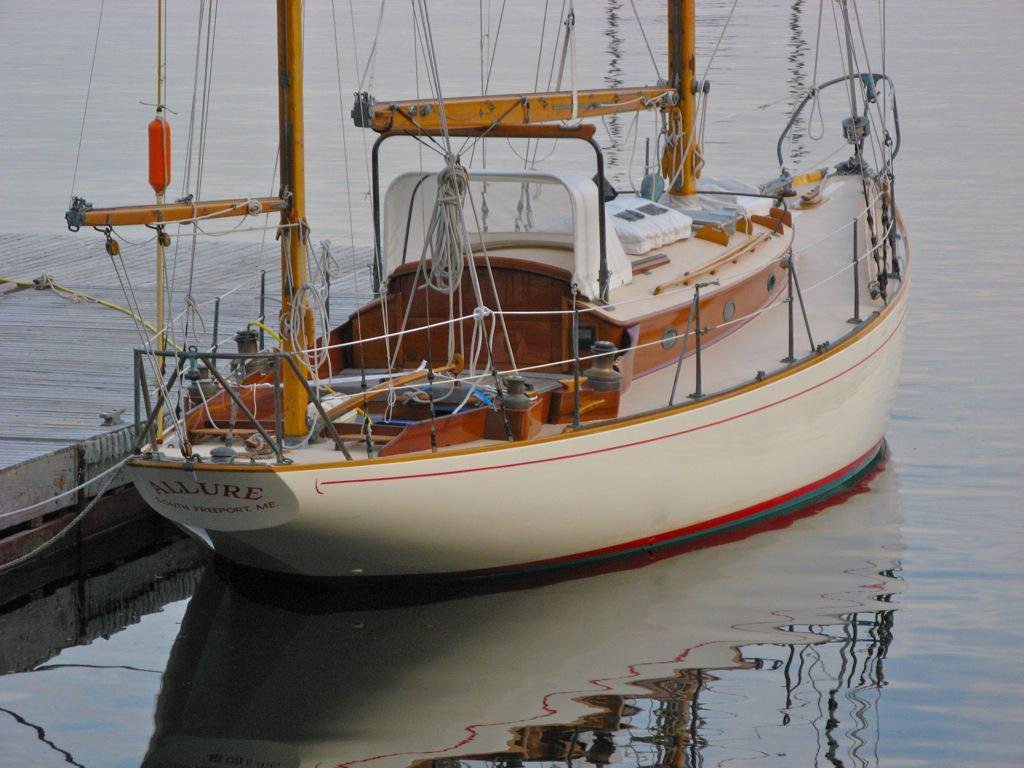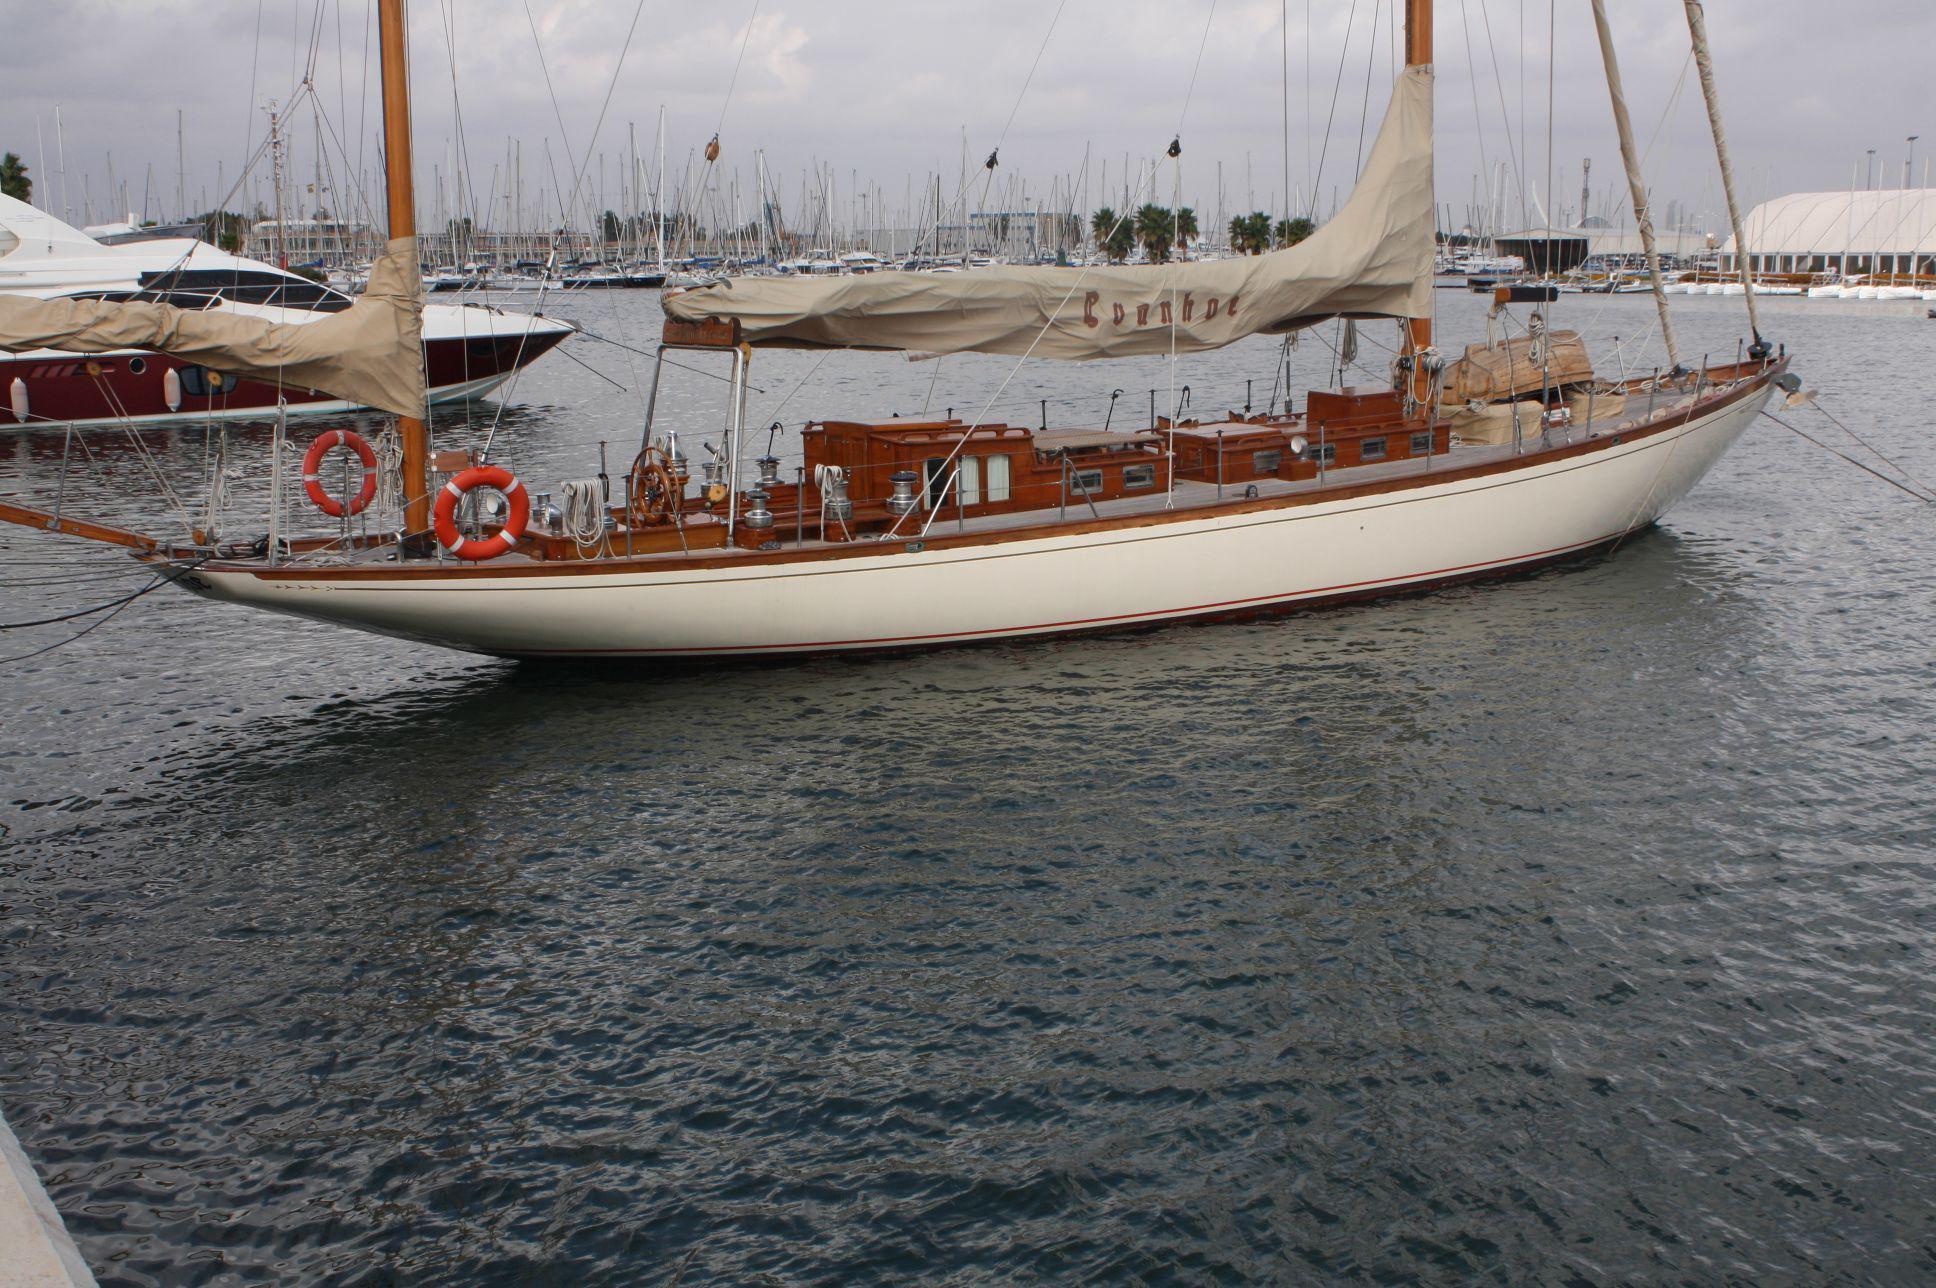The first image is the image on the left, the second image is the image on the right. Assess this claim about the two images: "The boat in the left image has a red flag hanging from its rear.". Correct or not? Answer yes or no. No. The first image is the image on the left, the second image is the image on the right. Evaluate the accuracy of this statement regarding the images: "A sailboat in one image has white billowing sails, but the sails of a boat in the other image are furled.". Is it true? Answer yes or no. No. 